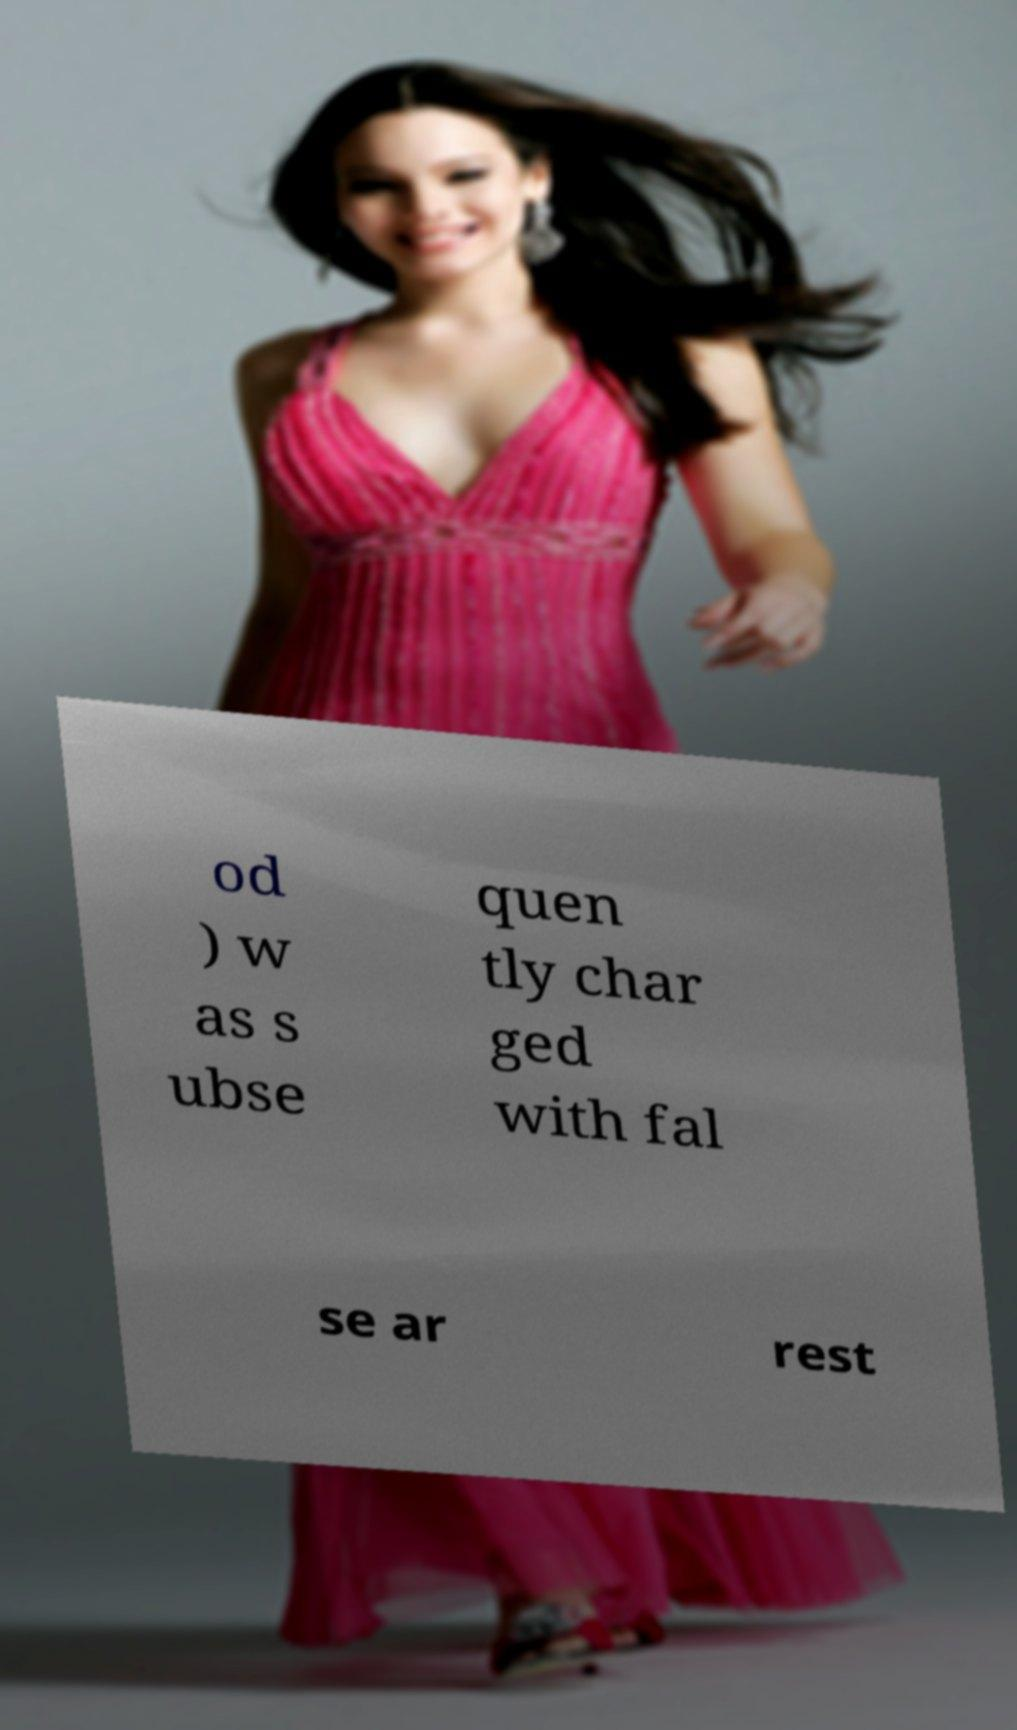Could you assist in decoding the text presented in this image and type it out clearly? od ) w as s ubse quen tly char ged with fal se ar rest 